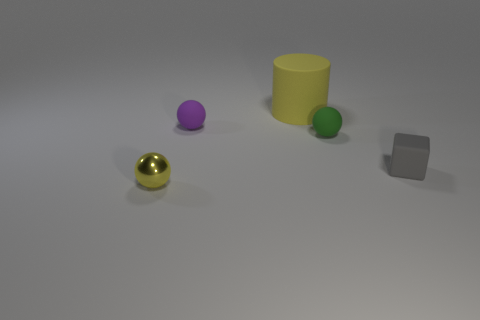Subtract all small yellow balls. How many balls are left? 2 Add 4 small blocks. How many objects exist? 9 Subtract all brown spheres. Subtract all blue cylinders. How many spheres are left? 3 Subtract all large cyan matte spheres. Subtract all small purple rubber things. How many objects are left? 4 Add 3 small green objects. How many small green objects are left? 4 Add 4 big things. How many big things exist? 5 Subtract 0 blue spheres. How many objects are left? 5 Subtract all cylinders. How many objects are left? 4 